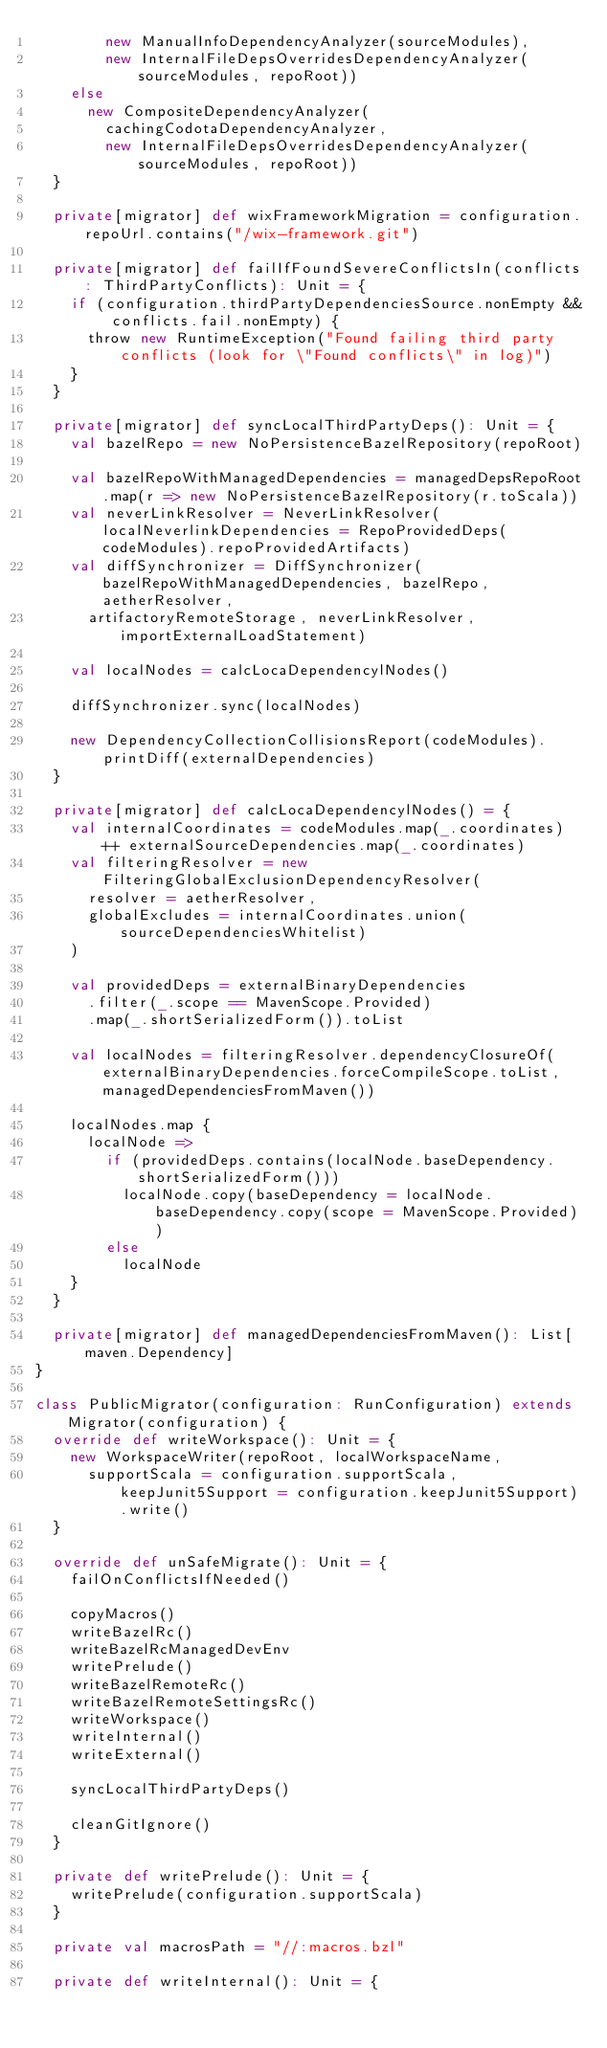<code> <loc_0><loc_0><loc_500><loc_500><_Scala_>        new ManualInfoDependencyAnalyzer(sourceModules),
        new InternalFileDepsOverridesDependencyAnalyzer(sourceModules, repoRoot))
    else
      new CompositeDependencyAnalyzer(
        cachingCodotaDependencyAnalyzer,
        new InternalFileDepsOverridesDependencyAnalyzer(sourceModules, repoRoot))
  }

  private[migrator] def wixFrameworkMigration = configuration.repoUrl.contains("/wix-framework.git")

  private[migrator] def failIfFoundSevereConflictsIn(conflicts: ThirdPartyConflicts): Unit = {
    if (configuration.thirdPartyDependenciesSource.nonEmpty && conflicts.fail.nonEmpty) {
      throw new RuntimeException("Found failing third party conflicts (look for \"Found conflicts\" in log)")
    }
  }

  private[migrator] def syncLocalThirdPartyDeps(): Unit = {
    val bazelRepo = new NoPersistenceBazelRepository(repoRoot)

    val bazelRepoWithManagedDependencies = managedDepsRepoRoot.map(r => new NoPersistenceBazelRepository(r.toScala))
    val neverLinkResolver = NeverLinkResolver(localNeverlinkDependencies = RepoProvidedDeps(codeModules).repoProvidedArtifacts)
    val diffSynchronizer = DiffSynchronizer(bazelRepoWithManagedDependencies, bazelRepo, aetherResolver,
      artifactoryRemoteStorage, neverLinkResolver, importExternalLoadStatement)

    val localNodes = calcLocaDependencylNodes()

    diffSynchronizer.sync(localNodes)

    new DependencyCollectionCollisionsReport(codeModules).printDiff(externalDependencies)
  }

  private[migrator] def calcLocaDependencylNodes() = {
    val internalCoordinates = codeModules.map(_.coordinates) ++ externalSourceDependencies.map(_.coordinates)
    val filteringResolver = new FilteringGlobalExclusionDependencyResolver(
      resolver = aetherResolver,
      globalExcludes = internalCoordinates.union(sourceDependenciesWhitelist)
    )

    val providedDeps = externalBinaryDependencies
      .filter(_.scope == MavenScope.Provided)
      .map(_.shortSerializedForm()).toList

    val localNodes = filteringResolver.dependencyClosureOf(externalBinaryDependencies.forceCompileScope.toList, managedDependenciesFromMaven())

    localNodes.map {
      localNode =>
        if (providedDeps.contains(localNode.baseDependency.shortSerializedForm()))
          localNode.copy(baseDependency = localNode.baseDependency.copy(scope = MavenScope.Provided))
        else
          localNode
    }
  }

  private[migrator] def managedDependenciesFromMaven(): List[maven.Dependency]
}

class PublicMigrator(configuration: RunConfiguration) extends Migrator(configuration) {
  override def writeWorkspace(): Unit = {
    new WorkspaceWriter(repoRoot, localWorkspaceName,
      supportScala = configuration.supportScala, keepJunit5Support = configuration.keepJunit5Support).write()
  }

  override def unSafeMigrate(): Unit = {
    failOnConflictsIfNeeded()

    copyMacros()
    writeBazelRc()
    writeBazelRcManagedDevEnv
    writePrelude()
    writeBazelRemoteRc()
    writeBazelRemoteSettingsRc()
    writeWorkspace()
    writeInternal()
    writeExternal()

    syncLocalThirdPartyDeps()

    cleanGitIgnore()
  }

  private def writePrelude(): Unit = {
    writePrelude(configuration.supportScala)
  }

  private val macrosPath = "//:macros.bzl"

  private def writeInternal(): Unit = {</code> 